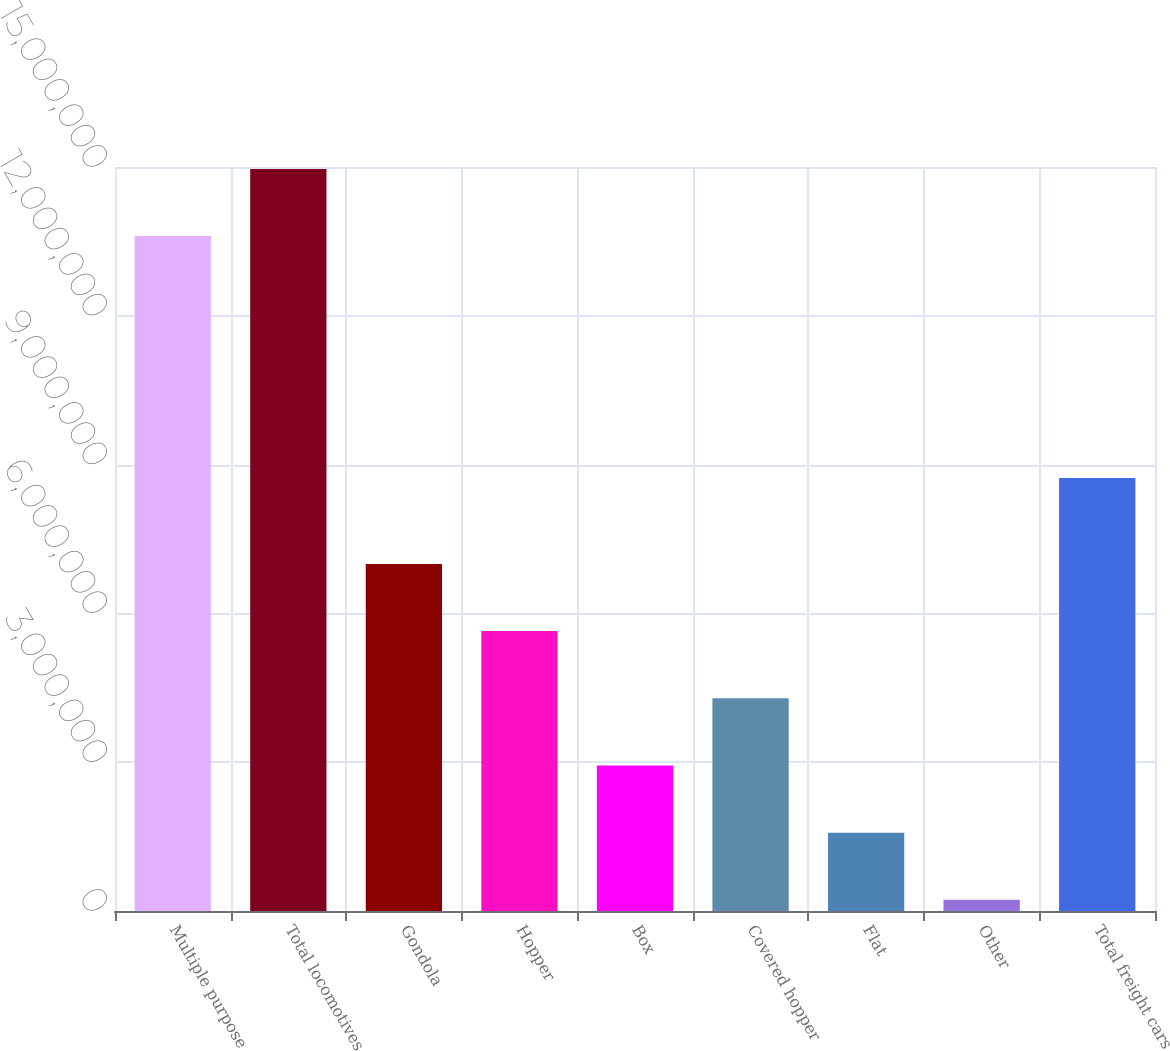Convert chart. <chart><loc_0><loc_0><loc_500><loc_500><bar_chart><fcel>Multiple purpose<fcel>Total locomotives<fcel>Gondola<fcel>Hopper<fcel>Box<fcel>Covered hopper<fcel>Flat<fcel>Other<fcel>Total freight cars<nl><fcel>1.36066e+07<fcel>1.49613e+07<fcel>6.99846e+06<fcel>5.64378e+06<fcel>2.93442e+06<fcel>4.2891e+06<fcel>1.57975e+06<fcel>225067<fcel>8.73102e+06<nl></chart> 